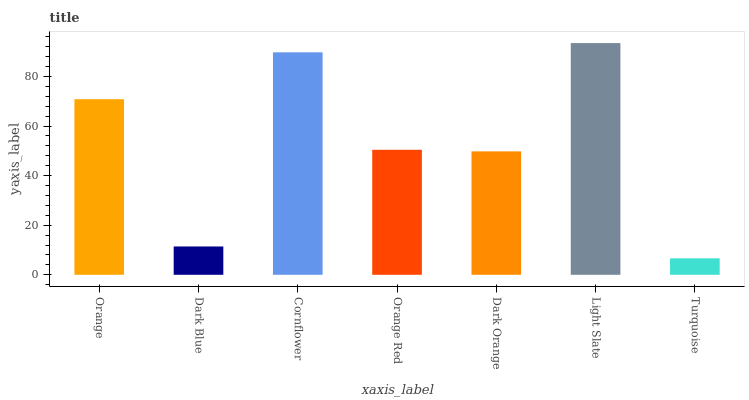Is Turquoise the minimum?
Answer yes or no. Yes. Is Light Slate the maximum?
Answer yes or no. Yes. Is Dark Blue the minimum?
Answer yes or no. No. Is Dark Blue the maximum?
Answer yes or no. No. Is Orange greater than Dark Blue?
Answer yes or no. Yes. Is Dark Blue less than Orange?
Answer yes or no. Yes. Is Dark Blue greater than Orange?
Answer yes or no. No. Is Orange less than Dark Blue?
Answer yes or no. No. Is Orange Red the high median?
Answer yes or no. Yes. Is Orange Red the low median?
Answer yes or no. Yes. Is Orange the high median?
Answer yes or no. No. Is Light Slate the low median?
Answer yes or no. No. 